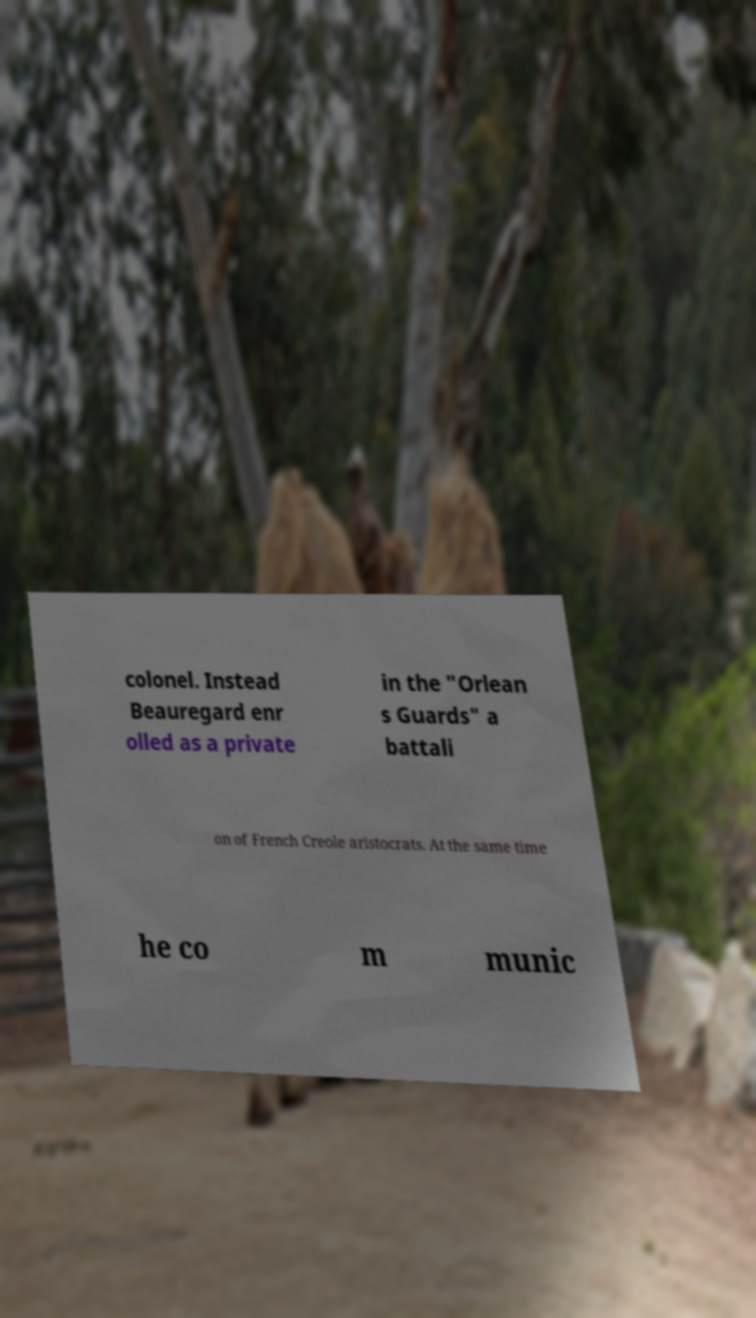There's text embedded in this image that I need extracted. Can you transcribe it verbatim? colonel. Instead Beauregard enr olled as a private in the "Orlean s Guards" a battali on of French Creole aristocrats. At the same time he co m munic 